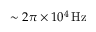Convert formula to latex. <formula><loc_0><loc_0><loc_500><loc_500>{ \sim 2 \pi \times 1 0 ^ { 4 } \, H z }</formula> 